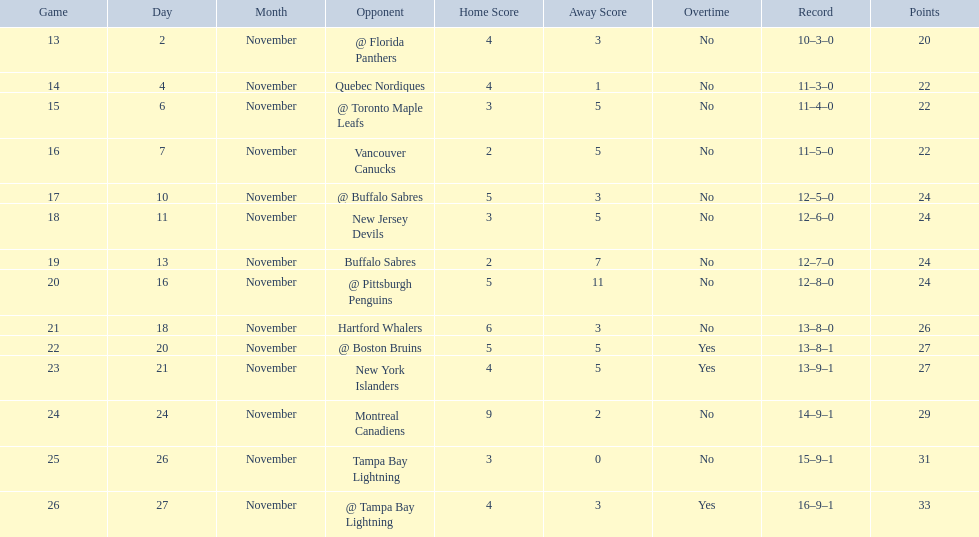Which teams scored 35 points or more in total? Hartford Whalers, @ Boston Bruins, New York Islanders, Montreal Canadiens, Tampa Bay Lightning, @ Tampa Bay Lightning. Of those teams, which team was the only one to score 3-0? Tampa Bay Lightning. 